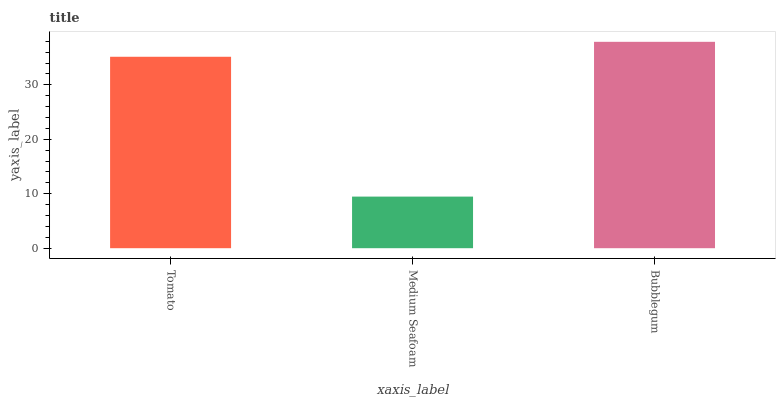Is Medium Seafoam the minimum?
Answer yes or no. Yes. Is Bubblegum the maximum?
Answer yes or no. Yes. Is Bubblegum the minimum?
Answer yes or no. No. Is Medium Seafoam the maximum?
Answer yes or no. No. Is Bubblegum greater than Medium Seafoam?
Answer yes or no. Yes. Is Medium Seafoam less than Bubblegum?
Answer yes or no. Yes. Is Medium Seafoam greater than Bubblegum?
Answer yes or no. No. Is Bubblegum less than Medium Seafoam?
Answer yes or no. No. Is Tomato the high median?
Answer yes or no. Yes. Is Tomato the low median?
Answer yes or no. Yes. Is Bubblegum the high median?
Answer yes or no. No. Is Medium Seafoam the low median?
Answer yes or no. No. 